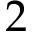<formula> <loc_0><loc_0><loc_500><loc_500>2</formula> 